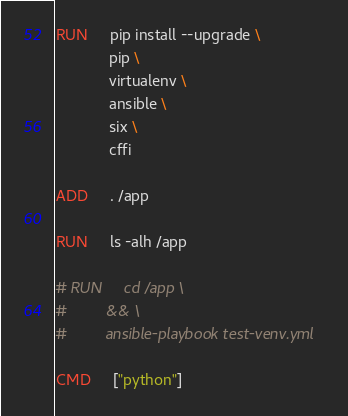Convert code to text. <code><loc_0><loc_0><loc_500><loc_500><_Dockerfile_>
RUN     pip install --upgrade \
            pip \
            virtualenv \
            ansible \
            six \
            cffi

ADD     . /app

RUN     ls -alh /app

# RUN     cd /app \
#         && \
#         ansible-playbook test-venv.yml

CMD     ["python"]
</code> 